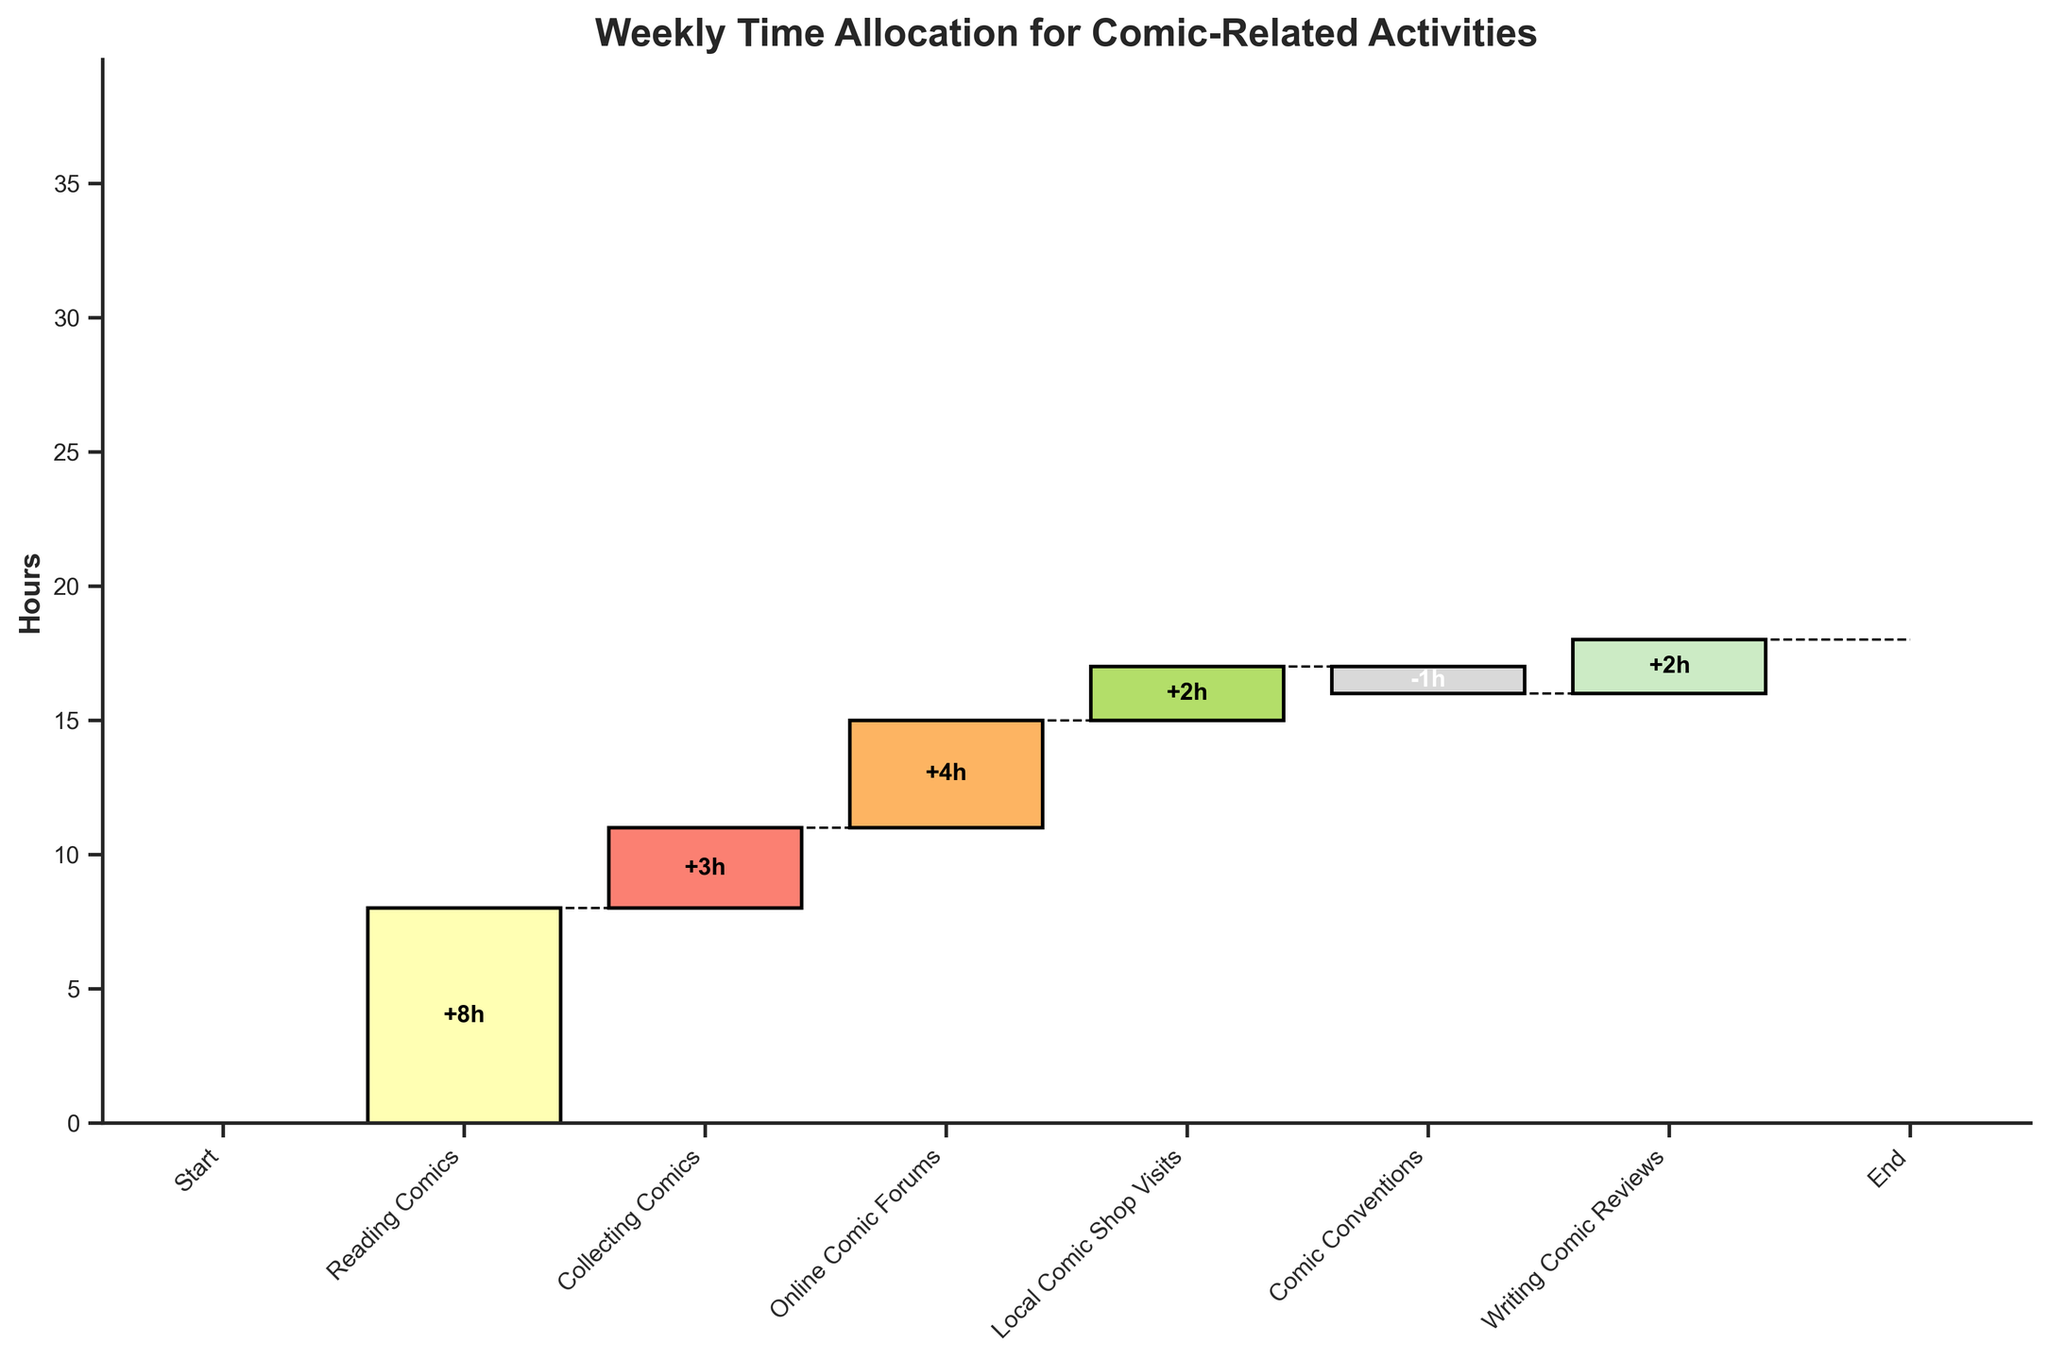How many hours are spent on reading comics in a week? The "Reading Comics" bar shows a value of 8 hours.
Answer: 8 What is the total time spent on activities besides comic conventions? Exclude the time spent on comic conventions (-1 hour), sum the values of the other activities (Reading, Collecting, Forums, Local Shop Visits, Writing Reviews): 8 + 3 + 4 + 2 + 2 = 19 hours.
Answer: 19 Which activity had the smallest positive time allocation? Compare the bars with positive values: Collecting Comics (3), Online Comic Forums (4), Local Comic Shop Visits (2), and Writing Comic Reviews (2). The smallest value among these is 2 hours.
Answer: Local Comic Shop Visits, Writing Comic Reviews What is the percentage of time spent on reading comics out of the total time allocated? Total time is 18 hours (End value), and 8 hours are spent on reading comics. Calculate the percentage: (8 / 18) * 100 = 44.44%.
Answer: 44.44% What is the net impact of comic conventions on the total time? The Comic Conventions bar shows a value of -1 hour, indicating a reduction in total time.
Answer: -1 How does the time spent on online comic forums compare to collecting comics? Online Comic Forums have 4 hours, while Collecting Comics has 3 hours. 4 is greater than 3.
Answer: More time is spent on online comic forums Which activity immediately follows reading comics? The waterfall chart shows "Collecting Comics" immediately following "Reading Comics."
Answer: Collecting Comics What would be the total time if comic conventions were not considered? Exclude Comic Conventions (-1 value). Calculate: Start + Reading + Collecting + Forums + Local Shop Visits + Writing Reviews = 0 + 8 + 3 + 4 + 2 + 2 = 19 hours.
Answer: 19 hours By how much does the time spent on writing comic reviews differ from the time spent on reading comics? Time spent on reading comics is 8 hours and writing comic reviews is 2 hours. Difference: 8 - 2 = 6 hours.
Answer: 6 hours 